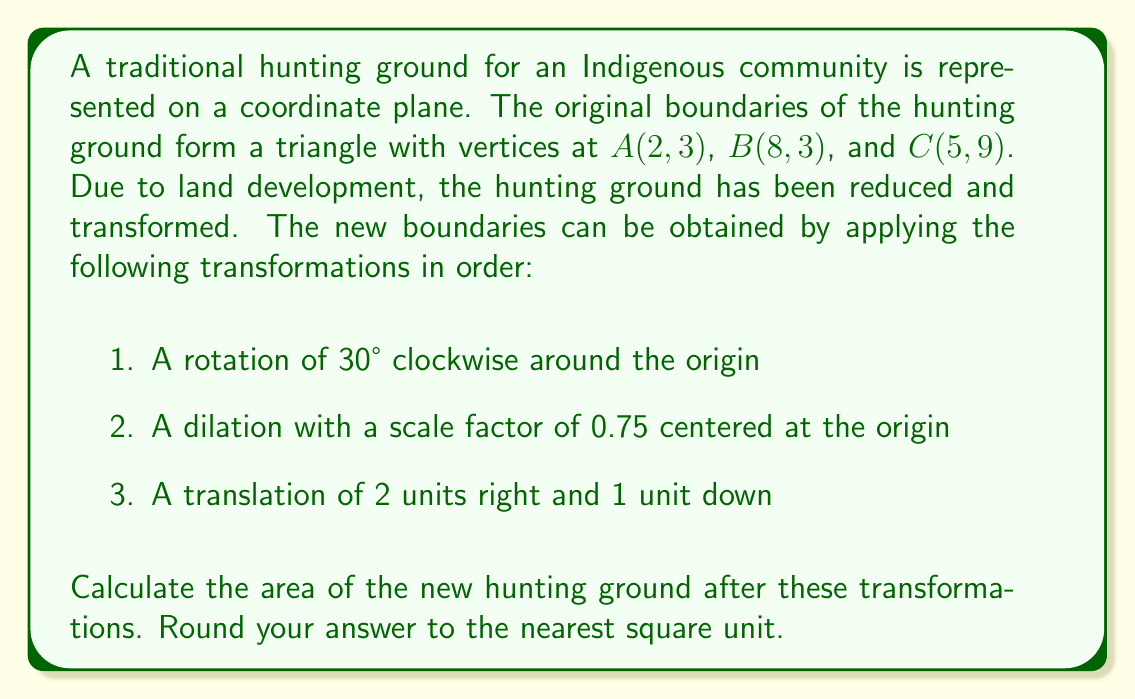Give your solution to this math problem. Let's approach this problem step-by-step:

1) First, we need to calculate the area of the original triangle. We can use the formula:

   $$ \text{Area} = \frac{1}{2}|x_1(y_2 - y_3) + x_2(y_3 - y_1) + x_3(y_1 - y_2)| $$

   $$ \text{Area} = \frac{1}{2}|2(3 - 9) + 8(9 - 3) + 5(3 - 3)| = 18 \text{ square units} $$

2) Now, let's apply the transformations in order:

   a) Rotation by 30° clockwise around the origin:
      The rotation matrix for this is:
      $$ R = \begin{pmatrix} \cos 30° & \sin 30° \\ -\sin 30° & \cos 30° \end{pmatrix} = \begin{pmatrix} \frac{\sqrt{3}}{2} & \frac{1}{2} \\ -\frac{1}{2} & \frac{\sqrt{3}}{2} \end{pmatrix} $$

   b) Dilation with scale factor 0.75:
      This is represented by the matrix:
      $$ D = \begin{pmatrix} 0.75 & 0 \\ 0 & 0.75 \end{pmatrix} $$

   c) Translation by 2 units right and 1 unit down:
      This is represented by adding $(2, -1)$ to each point.

3) Let's apply these transformations to each point:

   For point A(2, 3):
   $$ \begin{pmatrix} 2 \\ 3 \end{pmatrix} \xrightarrow{\text{rotate}} \begin{pmatrix} \frac{3\sqrt{3}+1}{2} \\ \frac{3-\sqrt{3}}{2} \end{pmatrix} \xrightarrow{\text{dilate}} \begin{pmatrix} \frac{3\sqrt{3}+1}{2.67} \\ \frac{3-\sqrt{3}}{2.67} \end{pmatrix} \xrightarrow{\text{translate}} \begin{pmatrix} \frac{3\sqrt{3}+1}{2.67} + 2 \\ \frac{3-\sqrt{3}}{2.67} - 1 \end{pmatrix} $$

   Similarly for B and C.

4) The new coordinates (rounded to 2 decimal places) are:
   A': (3.91, -0.12)
   B': (7.72, -3.37)
   C': (5.82, 4.63)

5) Using these new coordinates in the area formula:

   $$ \text{Area}_{\text{new}} = \frac{1}{2}|3.91(-3.37 - 4.63) + 7.72(4.63 - (-0.12)) + 5.82(-0.12 - (-3.37))| $$
   $$ = \frac{1}{2}|3.91(-7.99) + 7.72(4.75) + 5.82(3.25)| $$
   $$ = \frac{1}{2}|-31.24 + 36.67 + 18.92| $$
   $$ = \frac{1}{2}(24.35) = 12.18 \text{ square units} $$

6) Rounding to the nearest square unit: 12 square units.
Answer: 12 square units 